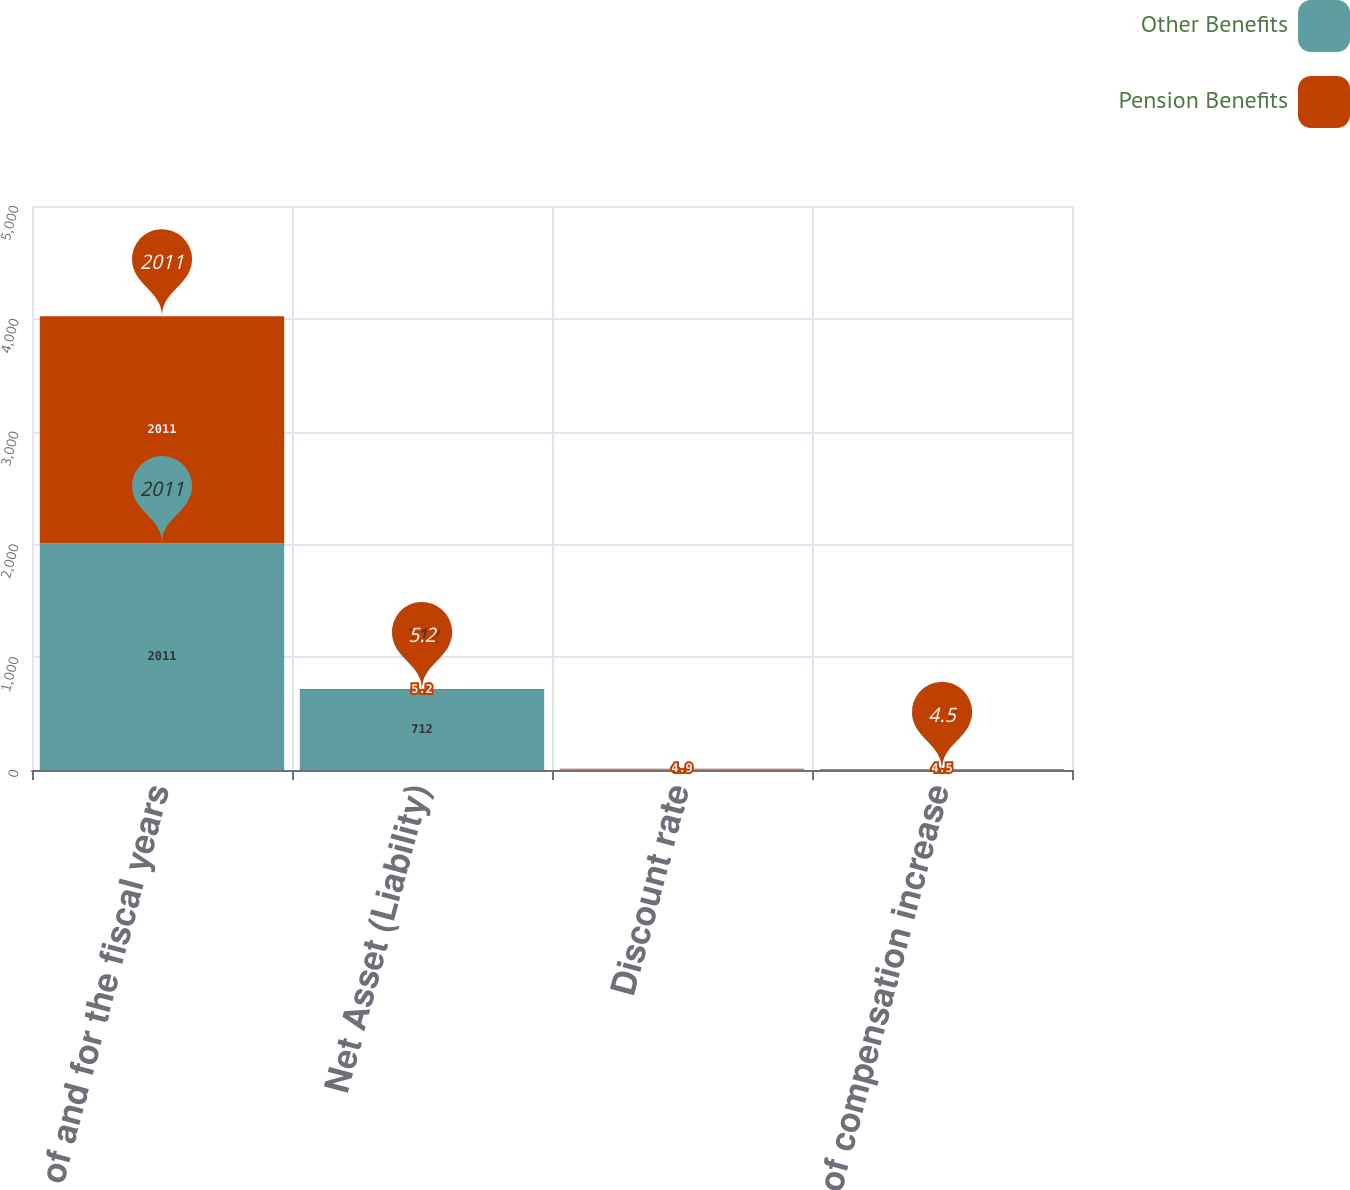Convert chart to OTSL. <chart><loc_0><loc_0><loc_500><loc_500><stacked_bar_chart><ecel><fcel>as of and for the fiscal years<fcel>Net Asset (Liability)<fcel>Discount rate<fcel>Rate of compensation increase<nl><fcel>Other Benefits<fcel>2011<fcel>712<fcel>5.2<fcel>4.2<nl><fcel>Pension Benefits<fcel>2011<fcel>5.2<fcel>4.9<fcel>4.5<nl></chart> 